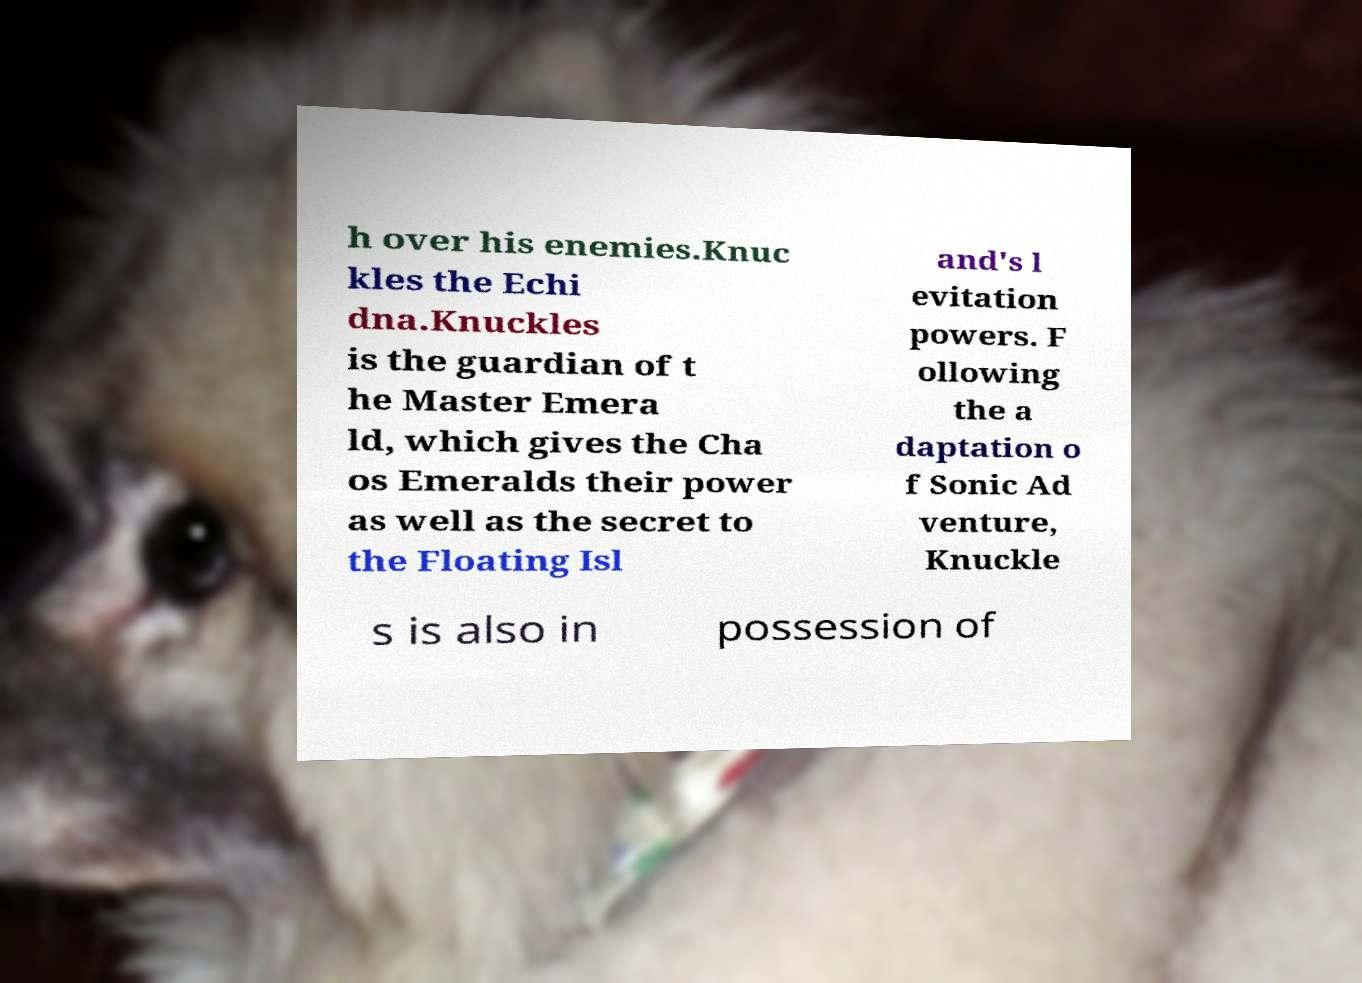Can you accurately transcribe the text from the provided image for me? h over his enemies.Knuc kles the Echi dna.Knuckles is the guardian of t he Master Emera ld, which gives the Cha os Emeralds their power as well as the secret to the Floating Isl and's l evitation powers. F ollowing the a daptation o f Sonic Ad venture, Knuckle s is also in possession of 